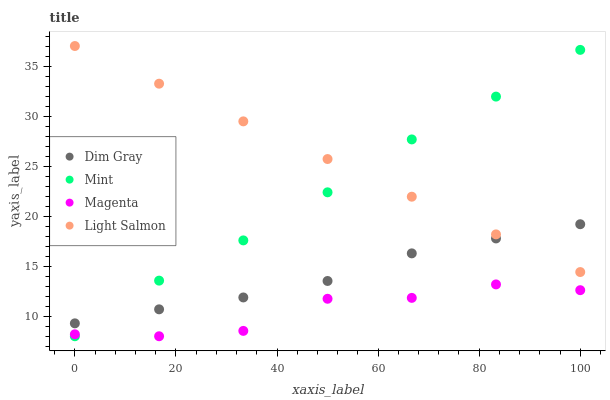Does Magenta have the minimum area under the curve?
Answer yes or no. Yes. Does Light Salmon have the maximum area under the curve?
Answer yes or no. Yes. Does Dim Gray have the minimum area under the curve?
Answer yes or no. No. Does Dim Gray have the maximum area under the curve?
Answer yes or no. No. Is Light Salmon the smoothest?
Answer yes or no. Yes. Is Magenta the roughest?
Answer yes or no. Yes. Is Dim Gray the smoothest?
Answer yes or no. No. Is Dim Gray the roughest?
Answer yes or no. No. Does Magenta have the lowest value?
Answer yes or no. Yes. Does Dim Gray have the lowest value?
Answer yes or no. No. Does Light Salmon have the highest value?
Answer yes or no. Yes. Does Dim Gray have the highest value?
Answer yes or no. No. Is Magenta less than Light Salmon?
Answer yes or no. Yes. Is Light Salmon greater than Magenta?
Answer yes or no. Yes. Does Magenta intersect Mint?
Answer yes or no. Yes. Is Magenta less than Mint?
Answer yes or no. No. Is Magenta greater than Mint?
Answer yes or no. No. Does Magenta intersect Light Salmon?
Answer yes or no. No. 